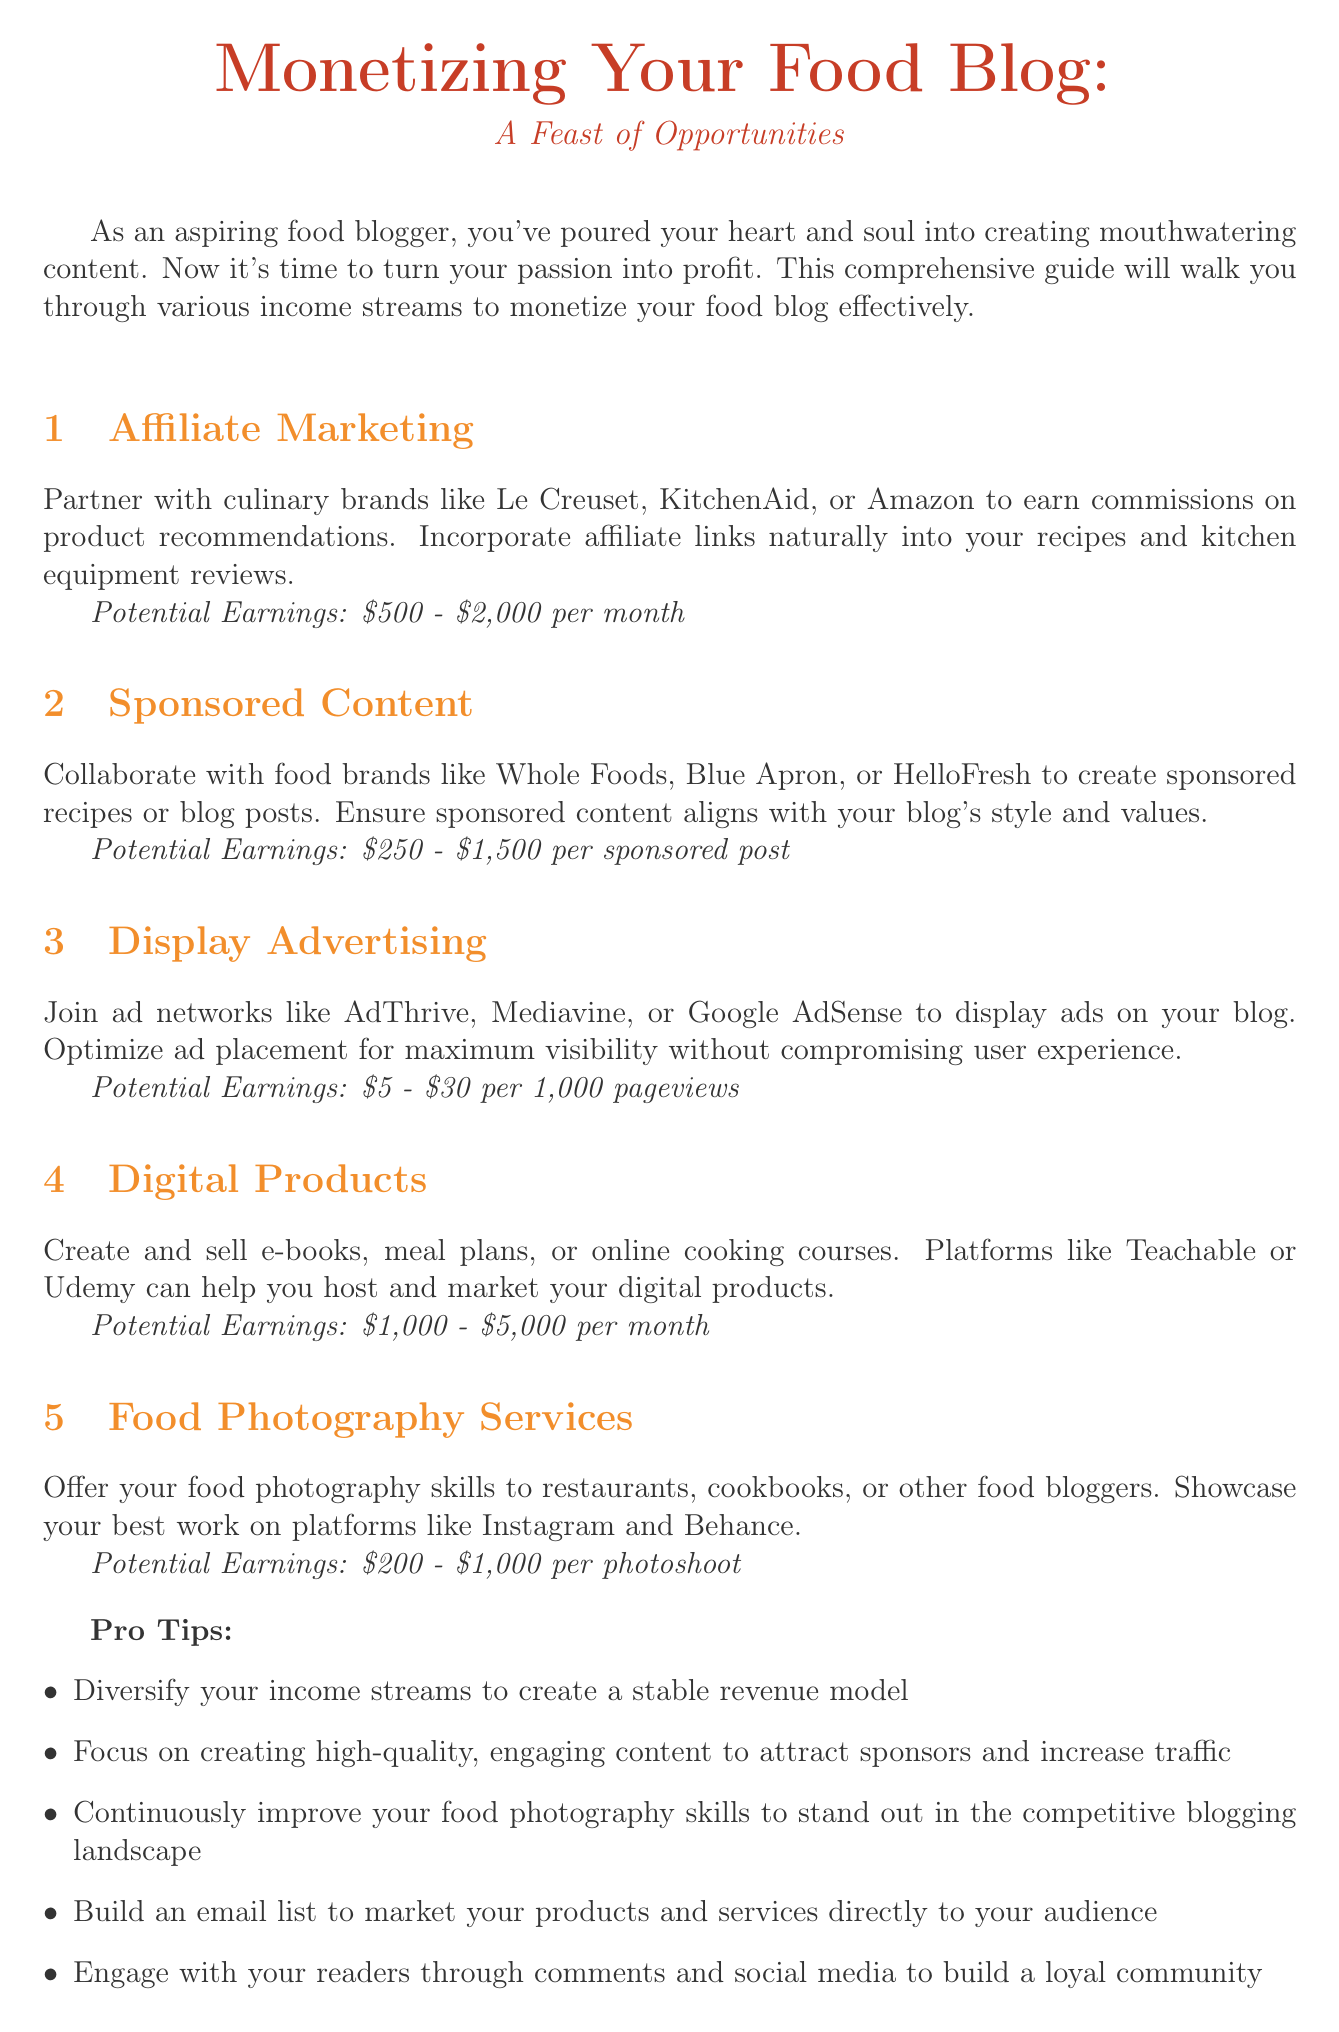What is the title of the newsletter? The title provides the main topic of the document, which is "Monetizing Your Food Blog: A Feast of Opportunities."
Answer: Monetizing Your Food Blog: A Feast of Opportunities What is the potential earnings range for Affiliate Marketing? The document specifies the earnings range for Affiliate Marketing, which is given in the section.
Answer: $500 - $2,000 per month Which income stream has the highest potential earnings stated in the document? By comparing the potential earnings from each section, we find that Digital Products has the highest range.
Answer: Digital Products What is one pro tip mentioned in the newsletter? The document provides a list of tips aimed at enhancing monetization strategies for food bloggers.
Answer: Diversify your income streams to create a stable revenue model How much can food bloggers earn from Display Advertising per 1,000 pageviews? The potential earnings for Display Advertising are provided explicitly in the corresponding section.
Answer: $5 - $30 per 1,000 pageviews What platform is suggested for hosting digital products? The document recommends certain platforms for hosting digital content in the Digital Products section.
Answer: Teachable or Udemy What does the graph depict? The graph visualizes the potential monthly income streams for food bloggers, showing data points for various income sources.
Answer: Potential Monthly Income Streams What content should sponsored posts align with? The reasoning requires understanding how to maintain brand integrity in sponsored content as mentioned in the section.
Answer: Blog's style and values How many sections discuss income streams in the newsletter? By counting the numbered sections listed in the document, we can determine the total.
Answer: 5 